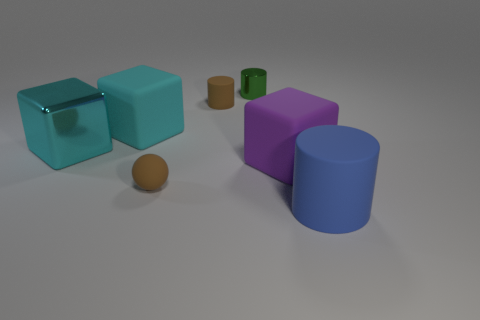Is there anything else that has the same color as the tiny rubber ball?
Give a very brief answer. Yes. How many objects are either big matte objects or large cubes right of the small brown cylinder?
Ensure brevity in your answer.  3. Is the brown matte cylinder the same size as the green thing?
Provide a short and direct response. Yes. There is a large blue object; are there any cylinders behind it?
Keep it short and to the point. Yes. What is the size of the object that is both to the right of the green thing and behind the big blue matte thing?
Ensure brevity in your answer.  Large. What number of objects are either brown spheres or big blue metallic balls?
Provide a succinct answer. 1. Does the purple block have the same size as the cylinder in front of the purple block?
Give a very brief answer. Yes. How big is the rubber cylinder behind the tiny thing that is in front of the tiny brown rubber object behind the rubber ball?
Your response must be concise. Small. Are any brown balls visible?
Make the answer very short. Yes. How many other large cubes have the same color as the large metallic block?
Give a very brief answer. 1. 